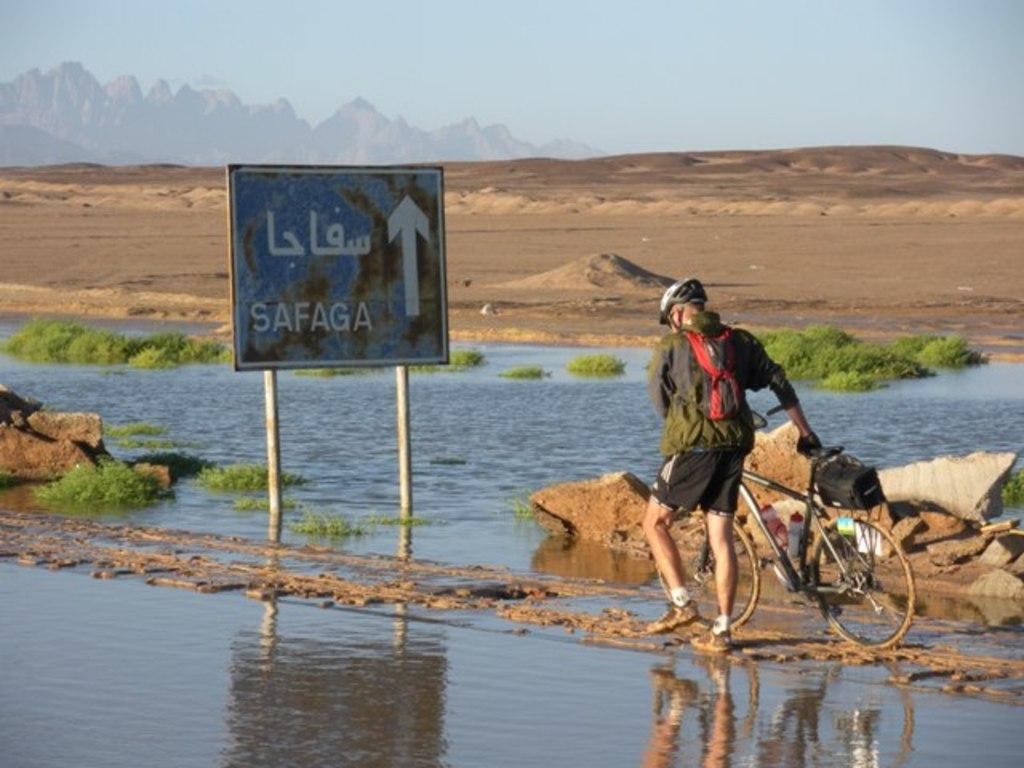What is present in the image that provides information or direction? There is a sign board in the image. Can you identify any living being in the image? Yes, there is a person in the image. What mode of transportation can be seen in the image? There is a bicycle in the image. What natural elements are visible in the image? Water, stones, grass, sand, and hills are visible in the image. What part of the natural environment is visible in the image? The sky is visible in the image. How many boys are depicted playing peacefully in the image? There is no reference to boys or any activity in the image. What type of linen is draped over the hills in the image? There is no linen present in the image; it features a sign board, a person, a bicycle, water, stones, grass, sand, hills, and the sky. 